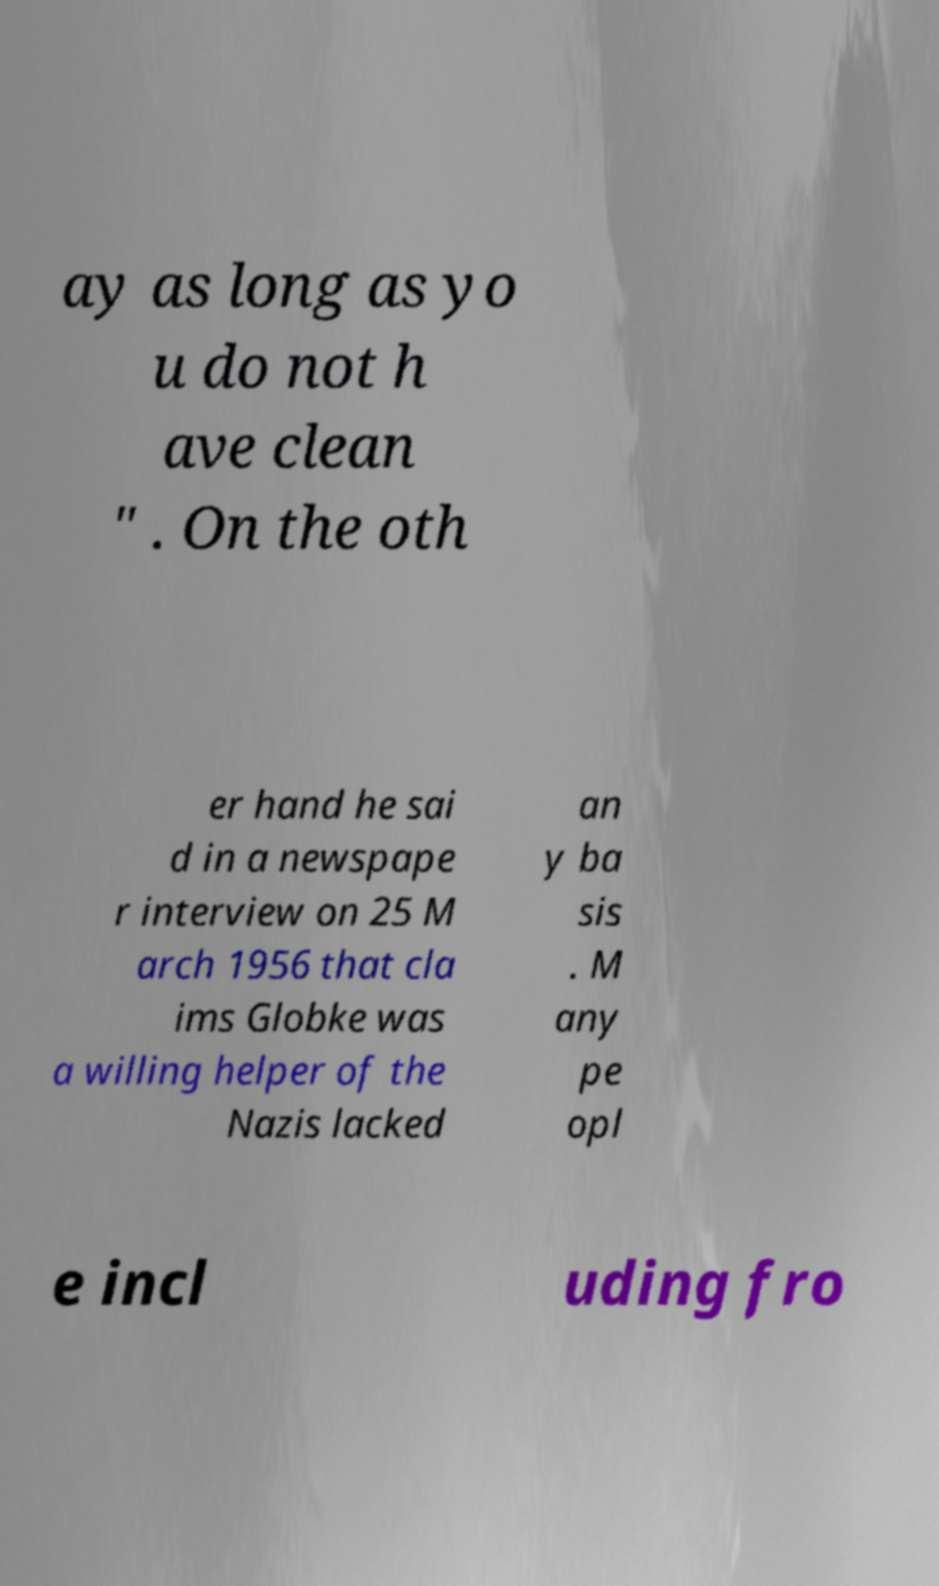Could you assist in decoding the text presented in this image and type it out clearly? ay as long as yo u do not h ave clean " . On the oth er hand he sai d in a newspape r interview on 25 M arch 1956 that cla ims Globke was a willing helper of the Nazis lacked an y ba sis . M any pe opl e incl uding fro 